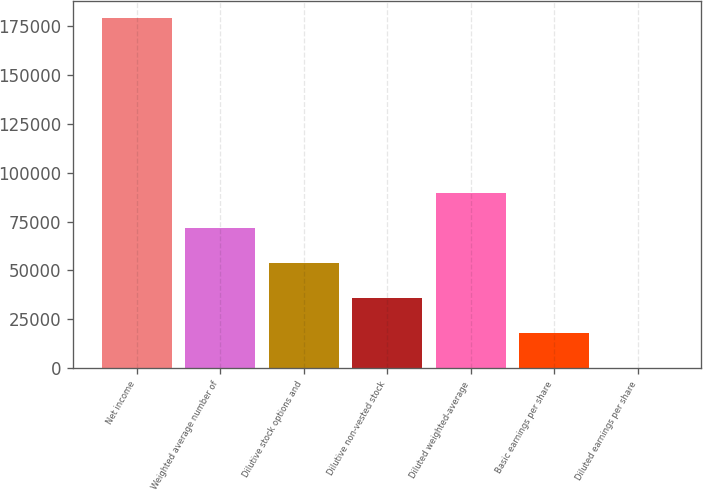Convert chart to OTSL. <chart><loc_0><loc_0><loc_500><loc_500><bar_chart><fcel>Net income<fcel>Weighted average number of<fcel>Dilutive stock options and<fcel>Dilutive non-vested stock<fcel>Diluted weighted-average<fcel>Basic earnings per share<fcel>Diluted earnings per share<nl><fcel>178981<fcel>71595.8<fcel>53698.3<fcel>35800.7<fcel>89493.3<fcel>17903.2<fcel>5.64<nl></chart> 